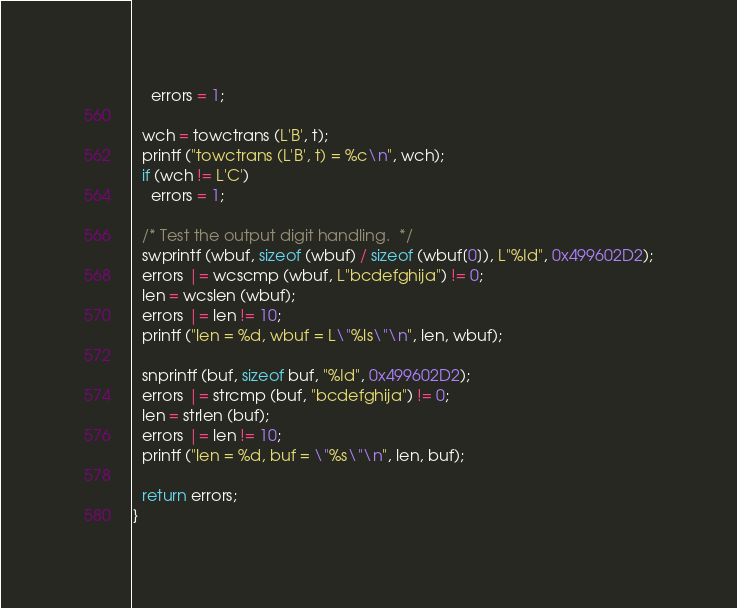<code> <loc_0><loc_0><loc_500><loc_500><_C_>    errors = 1;

  wch = towctrans (L'B', t);
  printf ("towctrans (L'B', t) = %c\n", wch);
  if (wch != L'C')
    errors = 1;

  /* Test the output digit handling.  */
  swprintf (wbuf, sizeof (wbuf) / sizeof (wbuf[0]), L"%Id", 0x499602D2);
  errors |= wcscmp (wbuf, L"bcdefghija") != 0;
  len = wcslen (wbuf);
  errors |= len != 10;
  printf ("len = %d, wbuf = L\"%ls\"\n", len, wbuf);

  snprintf (buf, sizeof buf, "%Id", 0x499602D2);
  errors |= strcmp (buf, "bcdefghija") != 0;
  len = strlen (buf);
  errors |= len != 10;
  printf ("len = %d, buf = \"%s\"\n", len, buf);

  return errors;
}
</code> 